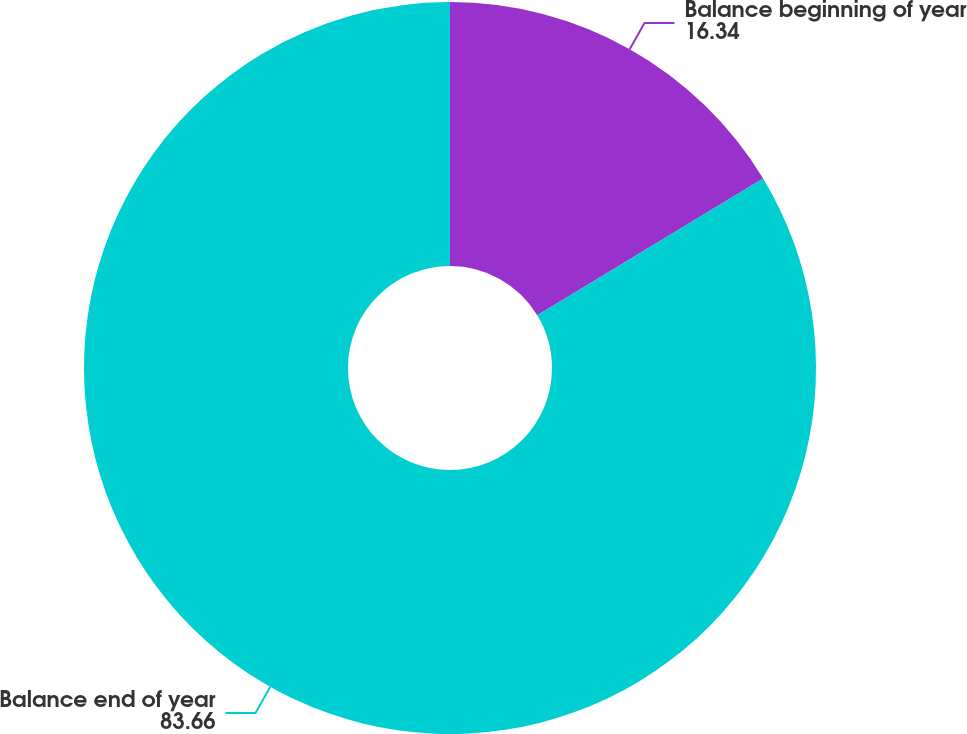Convert chart to OTSL. <chart><loc_0><loc_0><loc_500><loc_500><pie_chart><fcel>Balance beginning of year<fcel>Balance end of year<nl><fcel>16.34%<fcel>83.66%<nl></chart> 